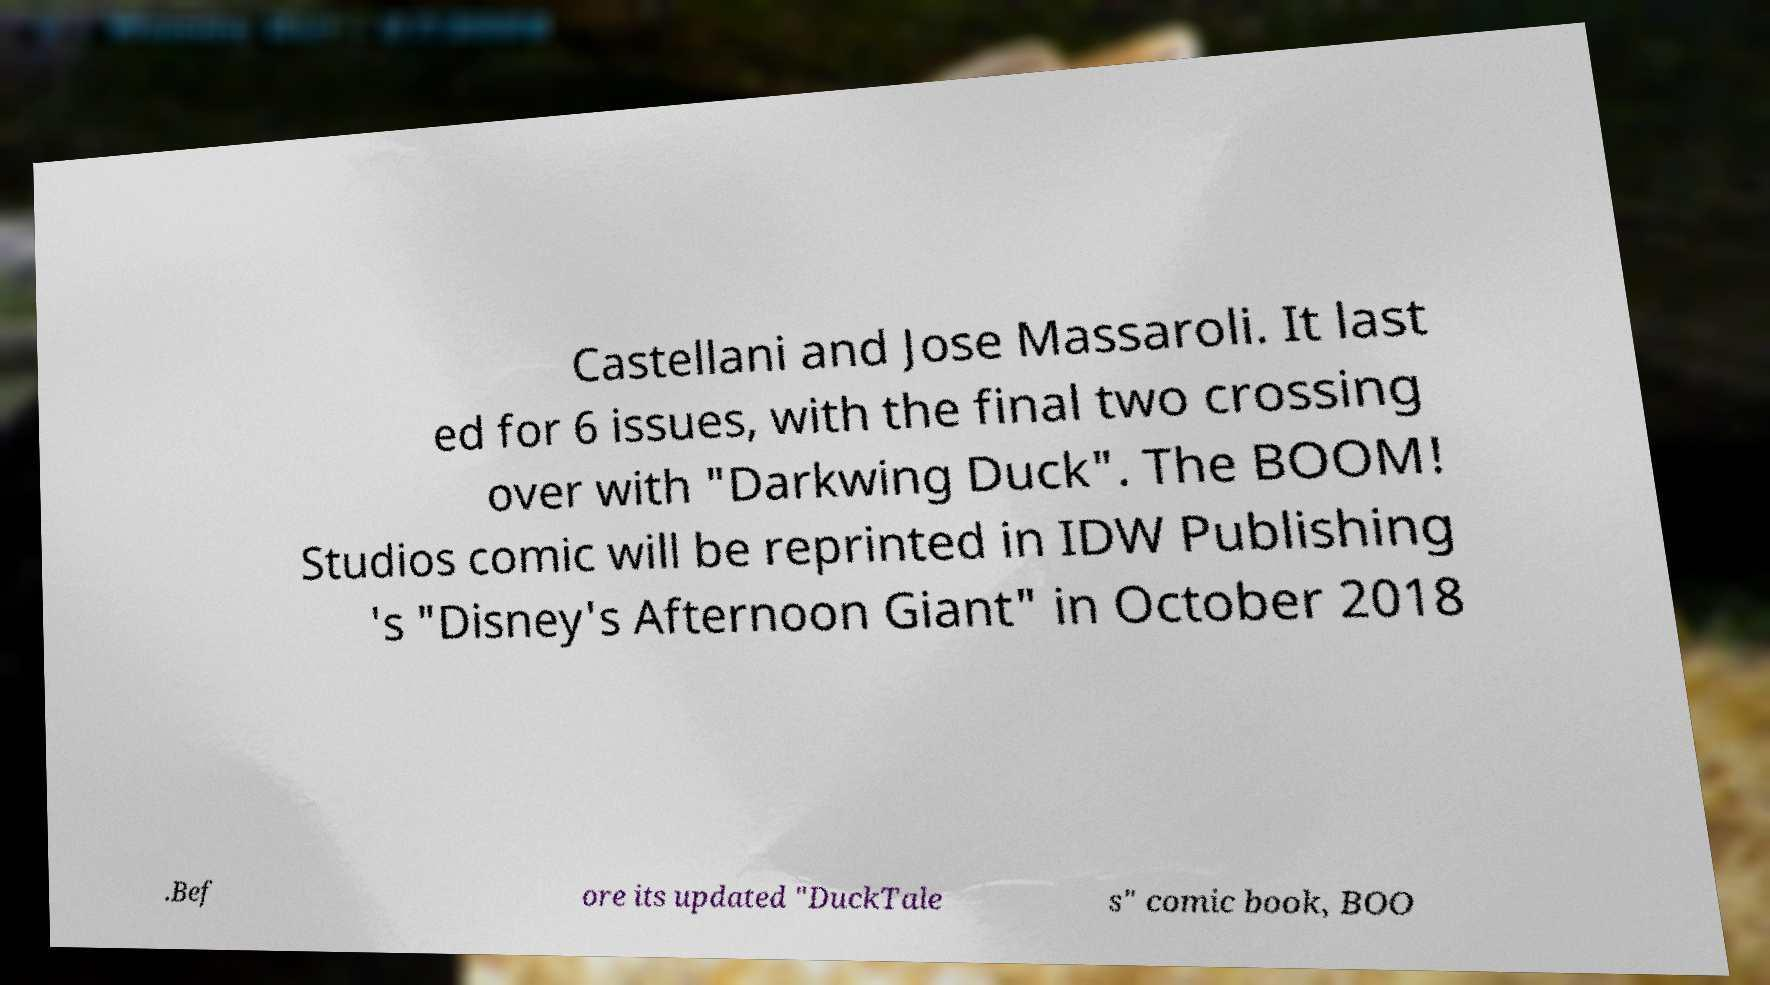Please identify and transcribe the text found in this image. Castellani and Jose Massaroli. It last ed for 6 issues, with the final two crossing over with "Darkwing Duck". The BOOM! Studios comic will be reprinted in IDW Publishing 's "Disney's Afternoon Giant" in October 2018 .Bef ore its updated "DuckTale s" comic book, BOO 